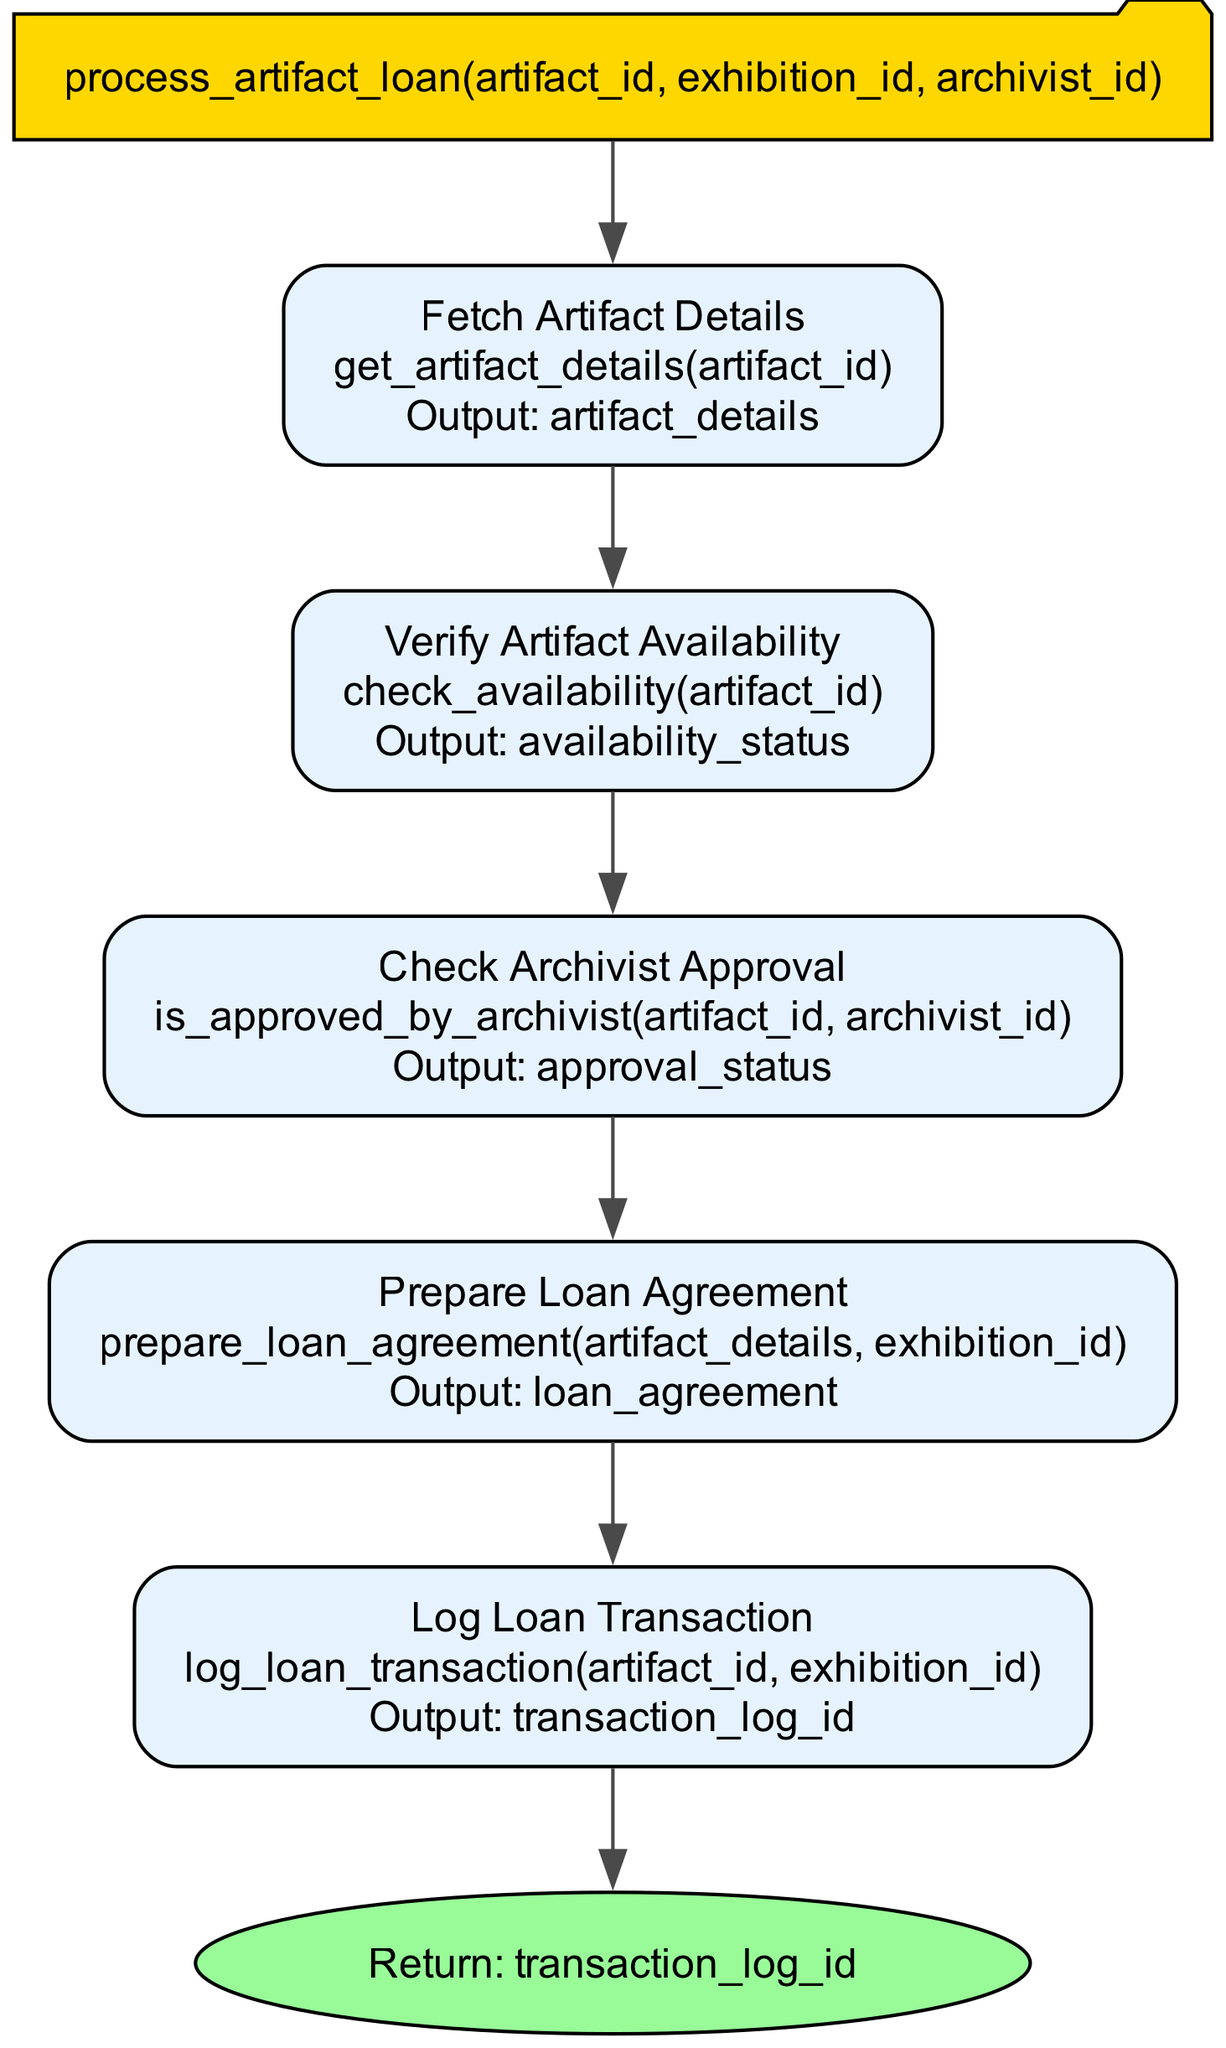What is the function name in the diagram? The function name is displayed prominently at the top of the diagram in a labeled node. It states "process_artifact_loan".
Answer: process_artifact_loan How many steps are involved in processing the artifact loan? The diagram has a series of sequential steps, and counting them reveals there are five distinct steps represented.
Answer: 5 What is the output of the step "Verify Artifact Availability"? Each step in the diagram specifies an output, and the step "Verify Artifact Availability" outputs "availability_status".
Answer: availability_status Which step checks the approval status by the archivist? The diagram clearly shows each step in sequence; "Check Archivist Approval" is identified as the step that checks for approval.
Answer: Check Archivist Approval What is the final output of the function? At the end of the flowchart, there is a return node that specifies what the function outputs upon completion. It states: "Return: transaction_log_id".
Answer: transaction_log_id What is the first step in the process? The first step is defined as the initial action taken in the sequence of activities; in this case, "Fetch Artifact Details".
Answer: Fetch Artifact Details Which function prepares the loan agreement? The diagram indicates each step alongside its respective function, and the step that handles the loan agreement is "Prepare Loan Agreement".
Answer: Prepare Loan Agreement Which function logs the loan transaction? In reviewing the process steps, the one responsible for logging the transaction is clearly labeled as "Log Loan Transaction".
Answer: Log Loan Transaction What parameters does the function take? The parameters are explicitly listed at the top of the function node, highlighting the inputs needed for execution, which are "artifact_id", "exhibition_id", and "archivist_id".
Answer: artifact_id, exhibition_id, archivist_id 